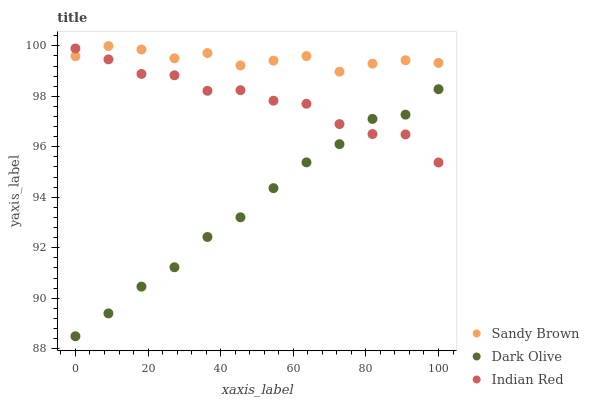Does Dark Olive have the minimum area under the curve?
Answer yes or no. Yes. Does Sandy Brown have the maximum area under the curve?
Answer yes or no. Yes. Does Indian Red have the minimum area under the curve?
Answer yes or no. No. Does Indian Red have the maximum area under the curve?
Answer yes or no. No. Is Dark Olive the smoothest?
Answer yes or no. Yes. Is Indian Red the roughest?
Answer yes or no. Yes. Is Sandy Brown the smoothest?
Answer yes or no. No. Is Sandy Brown the roughest?
Answer yes or no. No. Does Dark Olive have the lowest value?
Answer yes or no. Yes. Does Indian Red have the lowest value?
Answer yes or no. No. Does Sandy Brown have the highest value?
Answer yes or no. Yes. Does Indian Red have the highest value?
Answer yes or no. No. Is Dark Olive less than Sandy Brown?
Answer yes or no. Yes. Is Sandy Brown greater than Dark Olive?
Answer yes or no. Yes. Does Sandy Brown intersect Indian Red?
Answer yes or no. Yes. Is Sandy Brown less than Indian Red?
Answer yes or no. No. Is Sandy Brown greater than Indian Red?
Answer yes or no. No. Does Dark Olive intersect Sandy Brown?
Answer yes or no. No. 